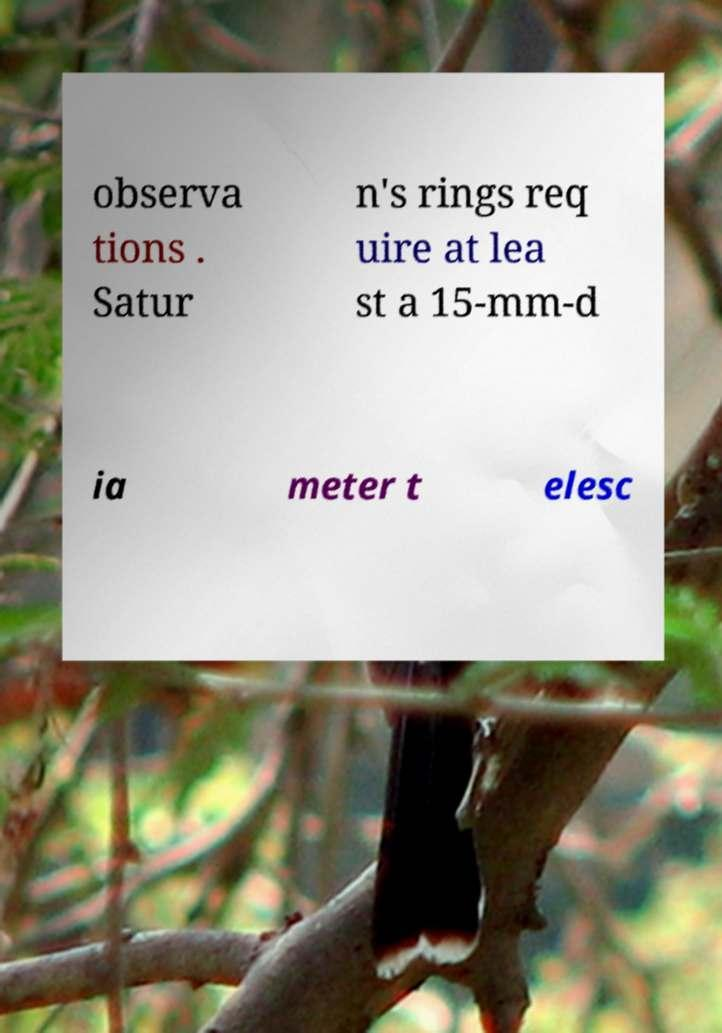Please identify and transcribe the text found in this image. observa tions . Satur n's rings req uire at lea st a 15-mm-d ia meter t elesc 